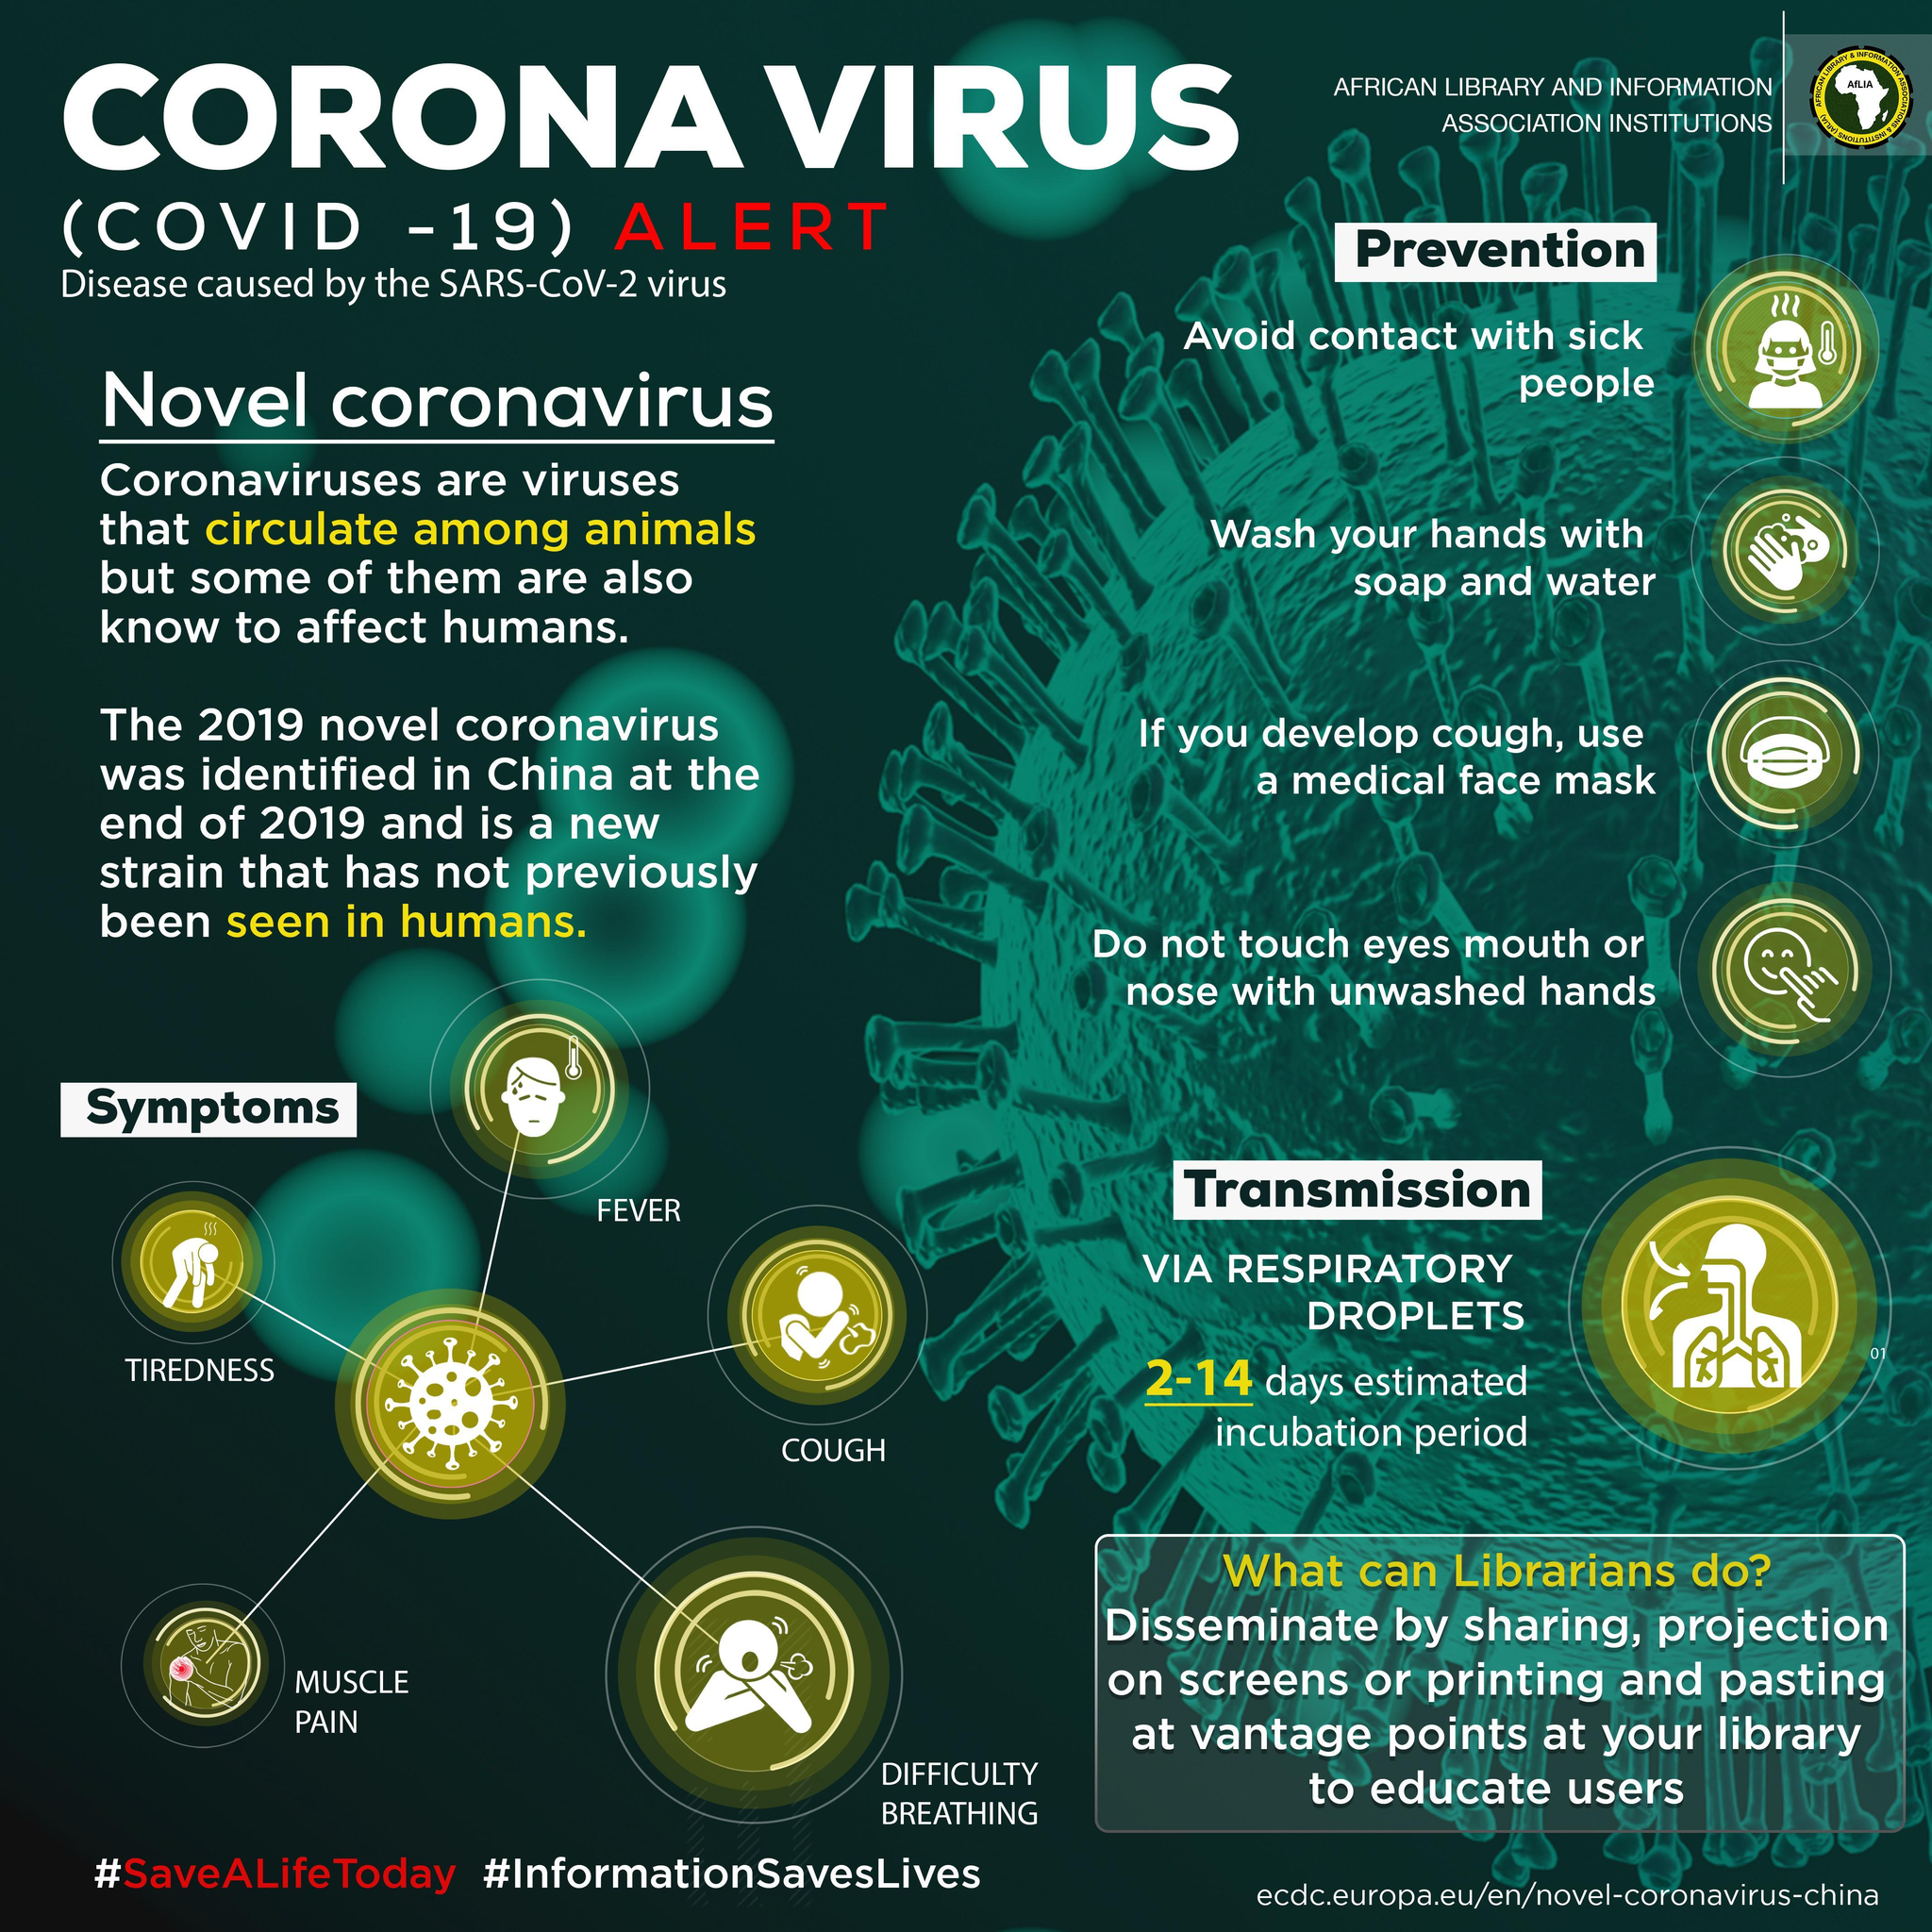What is the incubation period of the COVID-19 virus?
Answer the question with a short phrase. 2-14 days What are the symptoms of COVID-19 other than cough, fever & difficulty breathing? TIREDNESS, MUSCLE PAIN 